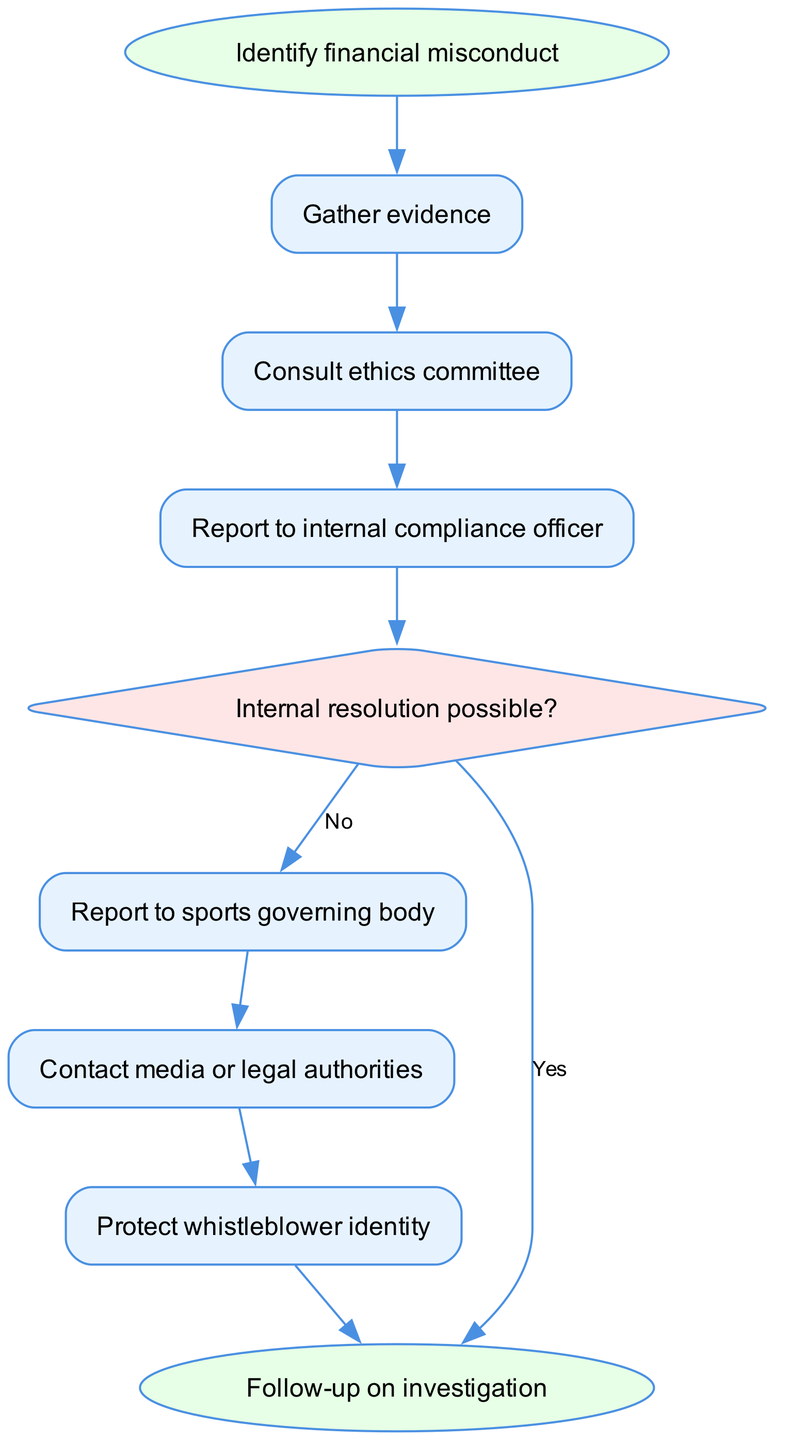What is the first step in the whistleblowing process? The first step is indicated by the 'start' node, which states "Identify financial misconduct." This is the initial action that needs to be taken in the process before any other actions can occur.
Answer: Identify financial misconduct How many nodes are present in the diagram? By counting each element listed in the data set under "elements," there are 10 nodes: start, step1, step2, step3, decision1, step4, step5, step6, and end.
Answer: 10 What happens if internal resolution is possible? If internal resolution is possible, the flow chart indicates that the process ends, as indicated by the link from 'decision1' to 'end' with the label "Yes." This suggests that no further action is required if the issue can be resolved internally.
Answer: Follow-up on investigation What is the last action to be taken in the process? The last action, indicated by the 'end' node, is "Follow-up on investigation." This is the final step after all previous actions have been completed.
Answer: Follow-up on investigation Which step follows "Report to internal compliance officer"? According to the connections in the diagram, the step that follows "Report to internal compliance officer" (step3) is to "Report to sports governing body" (step4), forming a logical flow from reporting internally to an external authority.
Answer: Report to sports governing body What is the purpose of contacting media or legal authorities? The diagram indicates that contacting media or legal authorities is the action to take following the reporting to the sports governing body. This suggests that the purpose is to escalate the issue further if necessary, based on the flow of actions in the event of unresolved issues.
Answer: Escalate the issue How is the identity of the whistleblower protected in the process? The process includes a step (step6) explicitly called "Protect whistleblower identity," indicating that there is a dedicated action to ensure the confidentiality and safety of the individual who reports the misconduct.
Answer: Protect whistleblower identity What is the decision point in the whistleblowing process? The decision point, as labeled in the diagram, is represented by "Internal resolution possible?" (decision1). It determines the flow of the process based on whether the issue can be resolved internally or if it needs to be escalated further.
Answer: Internal resolution possible? 